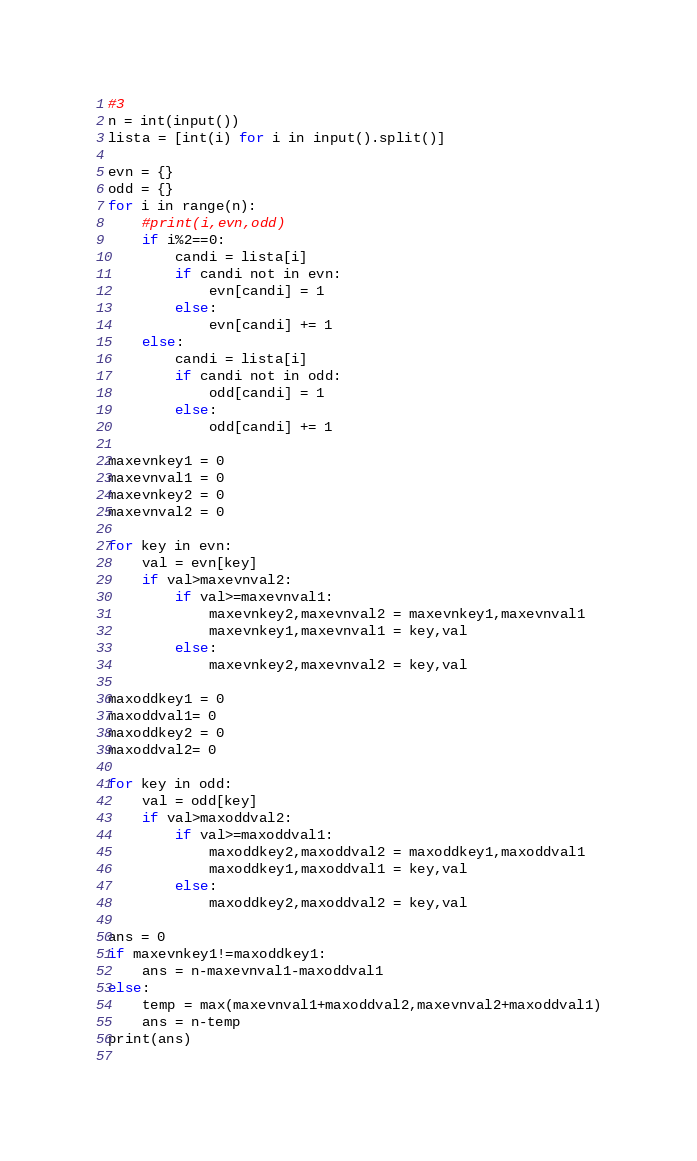<code> <loc_0><loc_0><loc_500><loc_500><_Python_>#3
n = int(input())
lista = [int(i) for i in input().split()]

evn = {}
odd = {}
for i in range(n):
    #print(i,evn,odd)
    if i%2==0:
        candi = lista[i]
        if candi not in evn:
            evn[candi] = 1
        else:
            evn[candi] += 1
    else:
        candi = lista[i]
        if candi not in odd:
            odd[candi] = 1
        else:
            odd[candi] += 1
        
maxevnkey1 = 0
maxevnval1 = 0
maxevnkey2 = 0
maxevnval2 = 0

for key in evn:
    val = evn[key]
    if val>maxevnval2:
        if val>=maxevnval1:
            maxevnkey2,maxevnval2 = maxevnkey1,maxevnval1
            maxevnkey1,maxevnval1 = key,val
        else:
            maxevnkey2,maxevnval2 = key,val

maxoddkey1 = 0
maxoddval1= 0
maxoddkey2 = 0
maxoddval2= 0

for key in odd:
    val = odd[key]
    if val>maxoddval2:
        if val>=maxoddval1:
            maxoddkey2,maxoddval2 = maxoddkey1,maxoddval1
            maxoddkey1,maxoddval1 = key,val
        else:
            maxoddkey2,maxoddval2 = key,val
            
ans = 0
if maxevnkey1!=maxoddkey1:
    ans = n-maxevnval1-maxoddval1
else:
    temp = max(maxevnval1+maxoddval2,maxevnval2+maxoddval1)
    ans = n-temp
print(ans)
    



</code> 